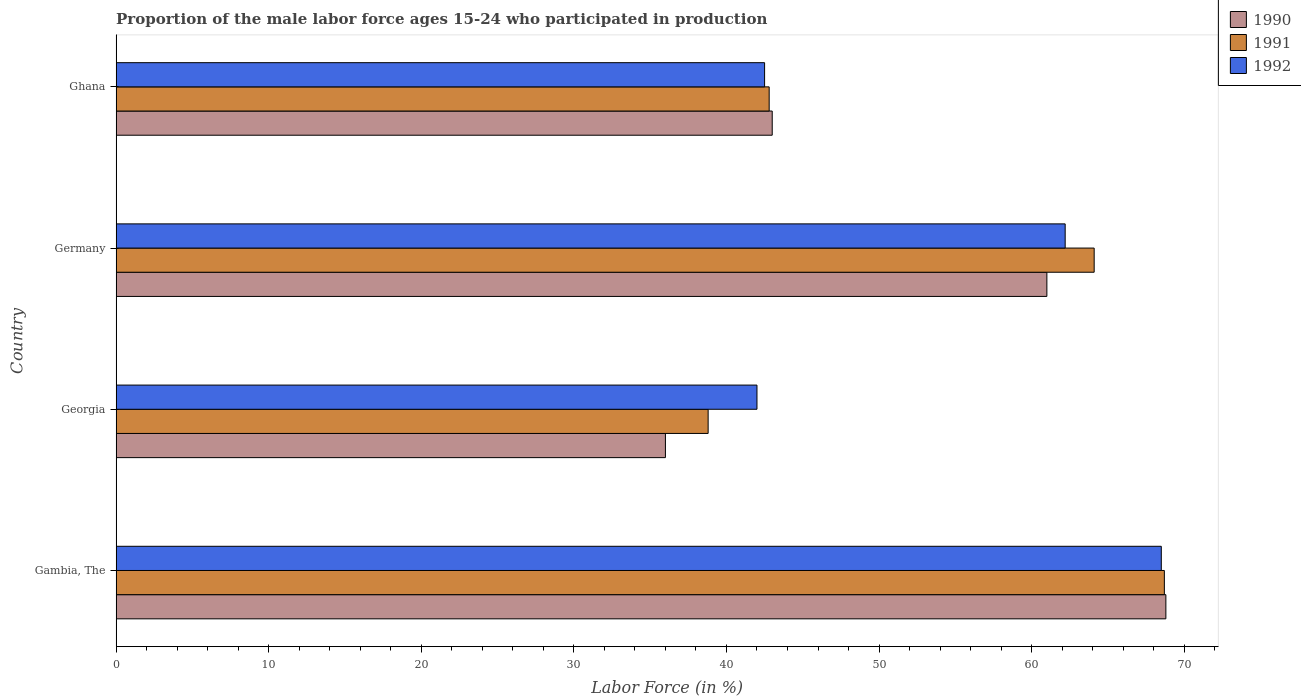How many groups of bars are there?
Provide a succinct answer. 4. Are the number of bars on each tick of the Y-axis equal?
Provide a succinct answer. Yes. How many bars are there on the 4th tick from the top?
Offer a very short reply. 3. In how many cases, is the number of bars for a given country not equal to the number of legend labels?
Your response must be concise. 0. What is the proportion of the male labor force who participated in production in 1991 in Georgia?
Your response must be concise. 38.8. Across all countries, what is the maximum proportion of the male labor force who participated in production in 1992?
Make the answer very short. 68.5. In which country was the proportion of the male labor force who participated in production in 1992 maximum?
Your answer should be very brief. Gambia, The. In which country was the proportion of the male labor force who participated in production in 1990 minimum?
Your response must be concise. Georgia. What is the total proportion of the male labor force who participated in production in 1992 in the graph?
Your answer should be very brief. 215.2. What is the difference between the proportion of the male labor force who participated in production in 1992 in Gambia, The and the proportion of the male labor force who participated in production in 1990 in Ghana?
Provide a succinct answer. 25.5. What is the average proportion of the male labor force who participated in production in 1992 per country?
Your answer should be very brief. 53.8. What is the difference between the proportion of the male labor force who participated in production in 1990 and proportion of the male labor force who participated in production in 1992 in Georgia?
Your answer should be very brief. -6. In how many countries, is the proportion of the male labor force who participated in production in 1990 greater than 42 %?
Ensure brevity in your answer.  3. What is the ratio of the proportion of the male labor force who participated in production in 1992 in Gambia, The to that in Germany?
Your answer should be compact. 1.1. Is the proportion of the male labor force who participated in production in 1991 in Georgia less than that in Ghana?
Keep it short and to the point. Yes. Is the difference between the proportion of the male labor force who participated in production in 1990 in Gambia, The and Germany greater than the difference between the proportion of the male labor force who participated in production in 1992 in Gambia, The and Germany?
Your answer should be very brief. Yes. What is the difference between the highest and the second highest proportion of the male labor force who participated in production in 1990?
Your answer should be compact. 7.8. What is the difference between the highest and the lowest proportion of the male labor force who participated in production in 1991?
Your answer should be very brief. 29.9. In how many countries, is the proportion of the male labor force who participated in production in 1991 greater than the average proportion of the male labor force who participated in production in 1991 taken over all countries?
Provide a succinct answer. 2. Is the sum of the proportion of the male labor force who participated in production in 1991 in Gambia, The and Georgia greater than the maximum proportion of the male labor force who participated in production in 1990 across all countries?
Offer a terse response. Yes. What does the 2nd bar from the bottom in Georgia represents?
Make the answer very short. 1991. Is it the case that in every country, the sum of the proportion of the male labor force who participated in production in 1992 and proportion of the male labor force who participated in production in 1991 is greater than the proportion of the male labor force who participated in production in 1990?
Your response must be concise. Yes. How many countries are there in the graph?
Make the answer very short. 4. What is the difference between two consecutive major ticks on the X-axis?
Give a very brief answer. 10. Are the values on the major ticks of X-axis written in scientific E-notation?
Keep it short and to the point. No. How many legend labels are there?
Offer a terse response. 3. How are the legend labels stacked?
Make the answer very short. Vertical. What is the title of the graph?
Your answer should be compact. Proportion of the male labor force ages 15-24 who participated in production. What is the label or title of the X-axis?
Give a very brief answer. Labor Force (in %). What is the Labor Force (in %) of 1990 in Gambia, The?
Offer a very short reply. 68.8. What is the Labor Force (in %) of 1991 in Gambia, The?
Make the answer very short. 68.7. What is the Labor Force (in %) of 1992 in Gambia, The?
Your answer should be very brief. 68.5. What is the Labor Force (in %) of 1991 in Georgia?
Make the answer very short. 38.8. What is the Labor Force (in %) of 1992 in Georgia?
Make the answer very short. 42. What is the Labor Force (in %) of 1990 in Germany?
Make the answer very short. 61. What is the Labor Force (in %) in 1991 in Germany?
Your answer should be compact. 64.1. What is the Labor Force (in %) in 1992 in Germany?
Offer a terse response. 62.2. What is the Labor Force (in %) in 1990 in Ghana?
Make the answer very short. 43. What is the Labor Force (in %) of 1991 in Ghana?
Offer a terse response. 42.8. What is the Labor Force (in %) in 1992 in Ghana?
Your answer should be very brief. 42.5. Across all countries, what is the maximum Labor Force (in %) in 1990?
Give a very brief answer. 68.8. Across all countries, what is the maximum Labor Force (in %) of 1991?
Provide a succinct answer. 68.7. Across all countries, what is the maximum Labor Force (in %) of 1992?
Make the answer very short. 68.5. Across all countries, what is the minimum Labor Force (in %) of 1991?
Offer a very short reply. 38.8. What is the total Labor Force (in %) in 1990 in the graph?
Provide a succinct answer. 208.8. What is the total Labor Force (in %) of 1991 in the graph?
Keep it short and to the point. 214.4. What is the total Labor Force (in %) in 1992 in the graph?
Offer a terse response. 215.2. What is the difference between the Labor Force (in %) of 1990 in Gambia, The and that in Georgia?
Provide a short and direct response. 32.8. What is the difference between the Labor Force (in %) in 1991 in Gambia, The and that in Georgia?
Keep it short and to the point. 29.9. What is the difference between the Labor Force (in %) in 1990 in Gambia, The and that in Germany?
Provide a short and direct response. 7.8. What is the difference between the Labor Force (in %) in 1992 in Gambia, The and that in Germany?
Offer a terse response. 6.3. What is the difference between the Labor Force (in %) in 1990 in Gambia, The and that in Ghana?
Provide a short and direct response. 25.8. What is the difference between the Labor Force (in %) of 1991 in Gambia, The and that in Ghana?
Keep it short and to the point. 25.9. What is the difference between the Labor Force (in %) of 1991 in Georgia and that in Germany?
Ensure brevity in your answer.  -25.3. What is the difference between the Labor Force (in %) of 1992 in Georgia and that in Germany?
Make the answer very short. -20.2. What is the difference between the Labor Force (in %) of 1990 in Georgia and that in Ghana?
Provide a succinct answer. -7. What is the difference between the Labor Force (in %) of 1992 in Georgia and that in Ghana?
Your response must be concise. -0.5. What is the difference between the Labor Force (in %) of 1991 in Germany and that in Ghana?
Your answer should be compact. 21.3. What is the difference between the Labor Force (in %) of 1992 in Germany and that in Ghana?
Offer a terse response. 19.7. What is the difference between the Labor Force (in %) in 1990 in Gambia, The and the Labor Force (in %) in 1991 in Georgia?
Your answer should be compact. 30. What is the difference between the Labor Force (in %) in 1990 in Gambia, The and the Labor Force (in %) in 1992 in Georgia?
Keep it short and to the point. 26.8. What is the difference between the Labor Force (in %) in 1991 in Gambia, The and the Labor Force (in %) in 1992 in Georgia?
Provide a succinct answer. 26.7. What is the difference between the Labor Force (in %) in 1991 in Gambia, The and the Labor Force (in %) in 1992 in Germany?
Give a very brief answer. 6.5. What is the difference between the Labor Force (in %) in 1990 in Gambia, The and the Labor Force (in %) in 1991 in Ghana?
Give a very brief answer. 26. What is the difference between the Labor Force (in %) of 1990 in Gambia, The and the Labor Force (in %) of 1992 in Ghana?
Offer a terse response. 26.3. What is the difference between the Labor Force (in %) in 1991 in Gambia, The and the Labor Force (in %) in 1992 in Ghana?
Offer a terse response. 26.2. What is the difference between the Labor Force (in %) of 1990 in Georgia and the Labor Force (in %) of 1991 in Germany?
Make the answer very short. -28.1. What is the difference between the Labor Force (in %) in 1990 in Georgia and the Labor Force (in %) in 1992 in Germany?
Ensure brevity in your answer.  -26.2. What is the difference between the Labor Force (in %) of 1991 in Georgia and the Labor Force (in %) of 1992 in Germany?
Keep it short and to the point. -23.4. What is the difference between the Labor Force (in %) of 1990 in Georgia and the Labor Force (in %) of 1991 in Ghana?
Your answer should be very brief. -6.8. What is the difference between the Labor Force (in %) of 1990 in Georgia and the Labor Force (in %) of 1992 in Ghana?
Your answer should be very brief. -6.5. What is the difference between the Labor Force (in %) of 1991 in Georgia and the Labor Force (in %) of 1992 in Ghana?
Give a very brief answer. -3.7. What is the difference between the Labor Force (in %) in 1990 in Germany and the Labor Force (in %) in 1992 in Ghana?
Your answer should be compact. 18.5. What is the difference between the Labor Force (in %) in 1991 in Germany and the Labor Force (in %) in 1992 in Ghana?
Ensure brevity in your answer.  21.6. What is the average Labor Force (in %) in 1990 per country?
Make the answer very short. 52.2. What is the average Labor Force (in %) in 1991 per country?
Your response must be concise. 53.6. What is the average Labor Force (in %) in 1992 per country?
Provide a short and direct response. 53.8. What is the difference between the Labor Force (in %) in 1990 and Labor Force (in %) in 1992 in Gambia, The?
Ensure brevity in your answer.  0.3. What is the difference between the Labor Force (in %) in 1990 and Labor Force (in %) in 1991 in Georgia?
Provide a short and direct response. -2.8. What is the difference between the Labor Force (in %) of 1990 and Labor Force (in %) of 1992 in Georgia?
Your answer should be compact. -6. What is the difference between the Labor Force (in %) of 1990 and Labor Force (in %) of 1991 in Germany?
Provide a short and direct response. -3.1. What is the difference between the Labor Force (in %) of 1990 and Labor Force (in %) of 1992 in Germany?
Give a very brief answer. -1.2. What is the difference between the Labor Force (in %) of 1990 and Labor Force (in %) of 1991 in Ghana?
Your answer should be very brief. 0.2. What is the difference between the Labor Force (in %) of 1990 and Labor Force (in %) of 1992 in Ghana?
Your answer should be compact. 0.5. What is the difference between the Labor Force (in %) of 1991 and Labor Force (in %) of 1992 in Ghana?
Your answer should be compact. 0.3. What is the ratio of the Labor Force (in %) of 1990 in Gambia, The to that in Georgia?
Provide a short and direct response. 1.91. What is the ratio of the Labor Force (in %) of 1991 in Gambia, The to that in Georgia?
Make the answer very short. 1.77. What is the ratio of the Labor Force (in %) in 1992 in Gambia, The to that in Georgia?
Ensure brevity in your answer.  1.63. What is the ratio of the Labor Force (in %) in 1990 in Gambia, The to that in Germany?
Provide a short and direct response. 1.13. What is the ratio of the Labor Force (in %) of 1991 in Gambia, The to that in Germany?
Ensure brevity in your answer.  1.07. What is the ratio of the Labor Force (in %) in 1992 in Gambia, The to that in Germany?
Offer a very short reply. 1.1. What is the ratio of the Labor Force (in %) in 1991 in Gambia, The to that in Ghana?
Make the answer very short. 1.61. What is the ratio of the Labor Force (in %) of 1992 in Gambia, The to that in Ghana?
Keep it short and to the point. 1.61. What is the ratio of the Labor Force (in %) of 1990 in Georgia to that in Germany?
Your answer should be compact. 0.59. What is the ratio of the Labor Force (in %) of 1991 in Georgia to that in Germany?
Provide a succinct answer. 0.61. What is the ratio of the Labor Force (in %) of 1992 in Georgia to that in Germany?
Ensure brevity in your answer.  0.68. What is the ratio of the Labor Force (in %) in 1990 in Georgia to that in Ghana?
Ensure brevity in your answer.  0.84. What is the ratio of the Labor Force (in %) of 1991 in Georgia to that in Ghana?
Make the answer very short. 0.91. What is the ratio of the Labor Force (in %) in 1992 in Georgia to that in Ghana?
Provide a short and direct response. 0.99. What is the ratio of the Labor Force (in %) of 1990 in Germany to that in Ghana?
Provide a short and direct response. 1.42. What is the ratio of the Labor Force (in %) of 1991 in Germany to that in Ghana?
Keep it short and to the point. 1.5. What is the ratio of the Labor Force (in %) in 1992 in Germany to that in Ghana?
Give a very brief answer. 1.46. What is the difference between the highest and the second highest Labor Force (in %) in 1990?
Ensure brevity in your answer.  7.8. What is the difference between the highest and the second highest Labor Force (in %) of 1991?
Ensure brevity in your answer.  4.6. What is the difference between the highest and the second highest Labor Force (in %) in 1992?
Offer a very short reply. 6.3. What is the difference between the highest and the lowest Labor Force (in %) in 1990?
Make the answer very short. 32.8. What is the difference between the highest and the lowest Labor Force (in %) in 1991?
Give a very brief answer. 29.9. What is the difference between the highest and the lowest Labor Force (in %) in 1992?
Offer a very short reply. 26.5. 